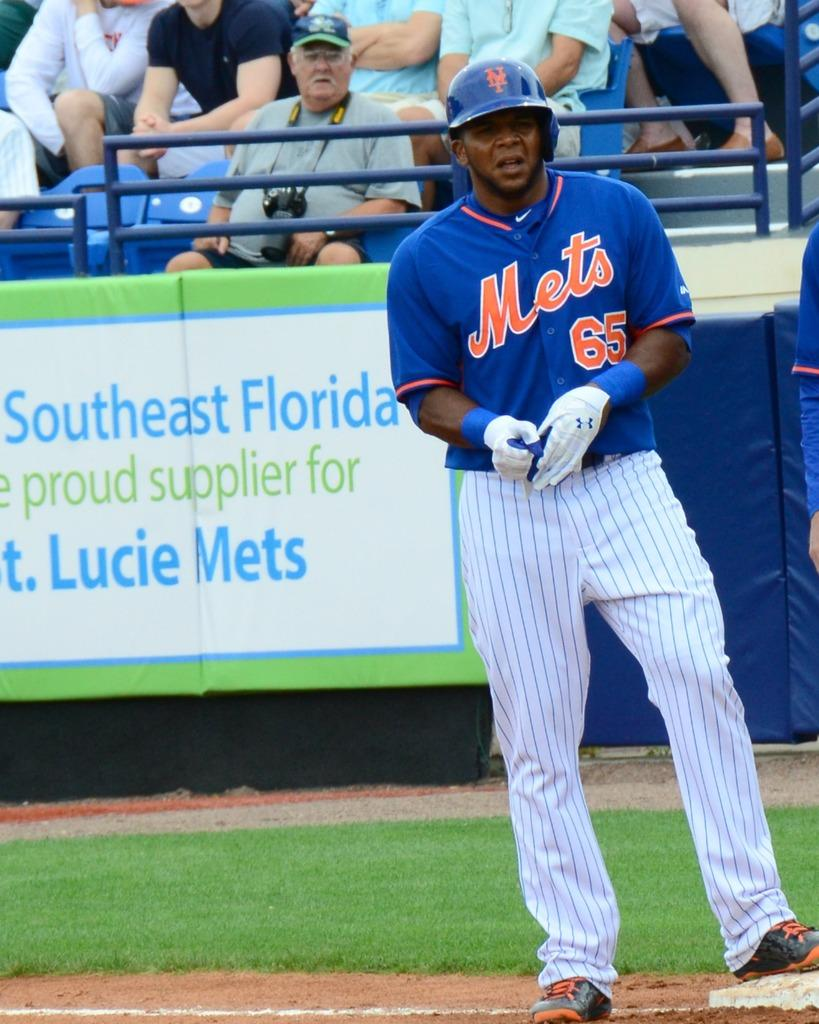<image>
Share a concise interpretation of the image provided. A baseball player wearing a number 65 Mets jersey stands in front of a crowd and sign advertising Southeast Florida suppliers. 